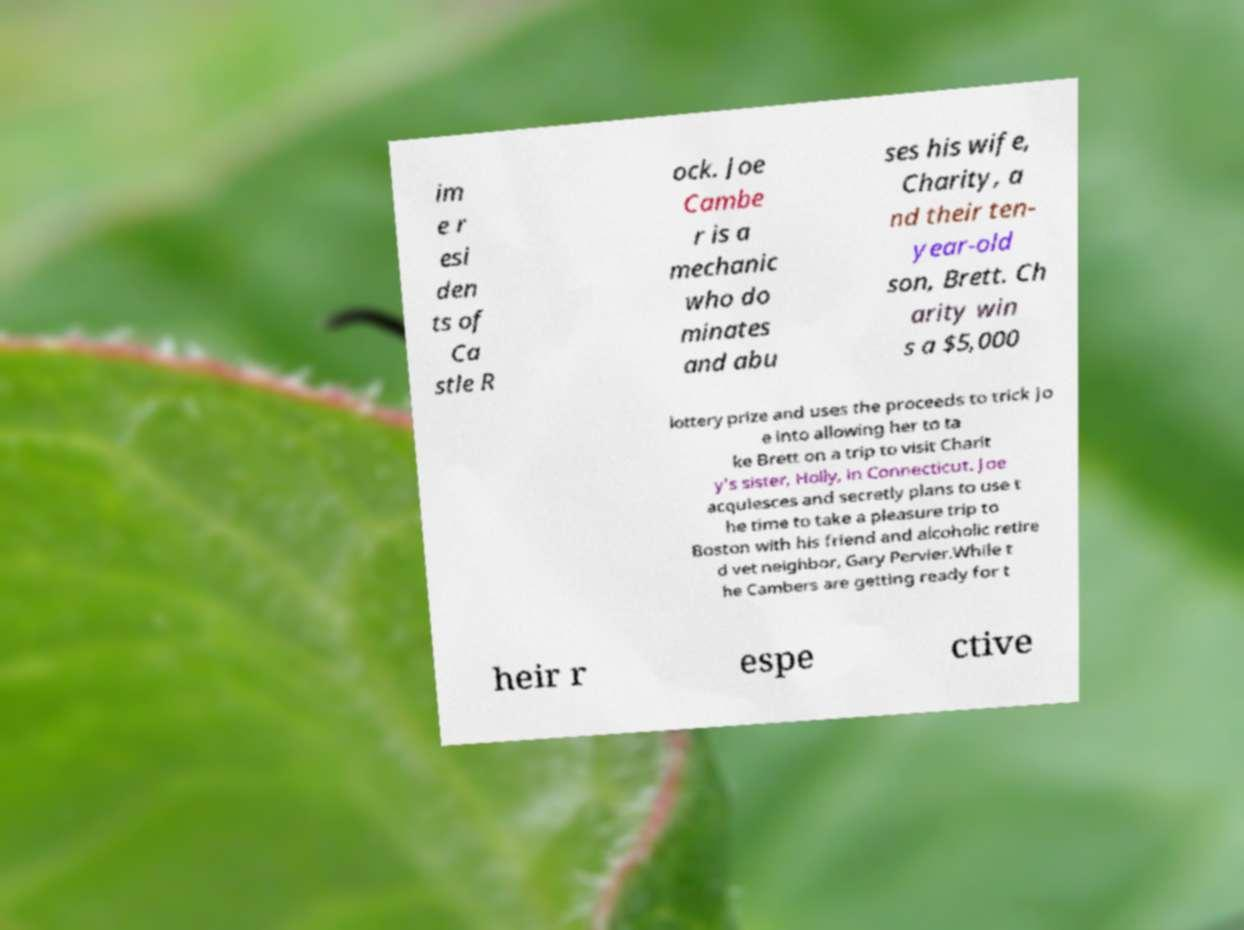Please identify and transcribe the text found in this image. im e r esi den ts of Ca stle R ock. Joe Cambe r is a mechanic who do minates and abu ses his wife, Charity, a nd their ten- year-old son, Brett. Ch arity win s a $5,000 lottery prize and uses the proceeds to trick Jo e into allowing her to ta ke Brett on a trip to visit Charit y's sister, Holly, in Connecticut. Joe acquiesces and secretly plans to use t he time to take a pleasure trip to Boston with his friend and alcoholic retire d vet neighbor, Gary Pervier.While t he Cambers are getting ready for t heir r espe ctive 